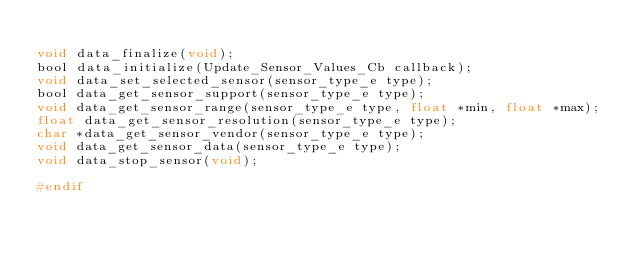Convert code to text. <code><loc_0><loc_0><loc_500><loc_500><_C_>
void data_finalize(void);
bool data_initialize(Update_Sensor_Values_Cb callback);
void data_set_selected_sensor(sensor_type_e type);
bool data_get_sensor_support(sensor_type_e type);
void data_get_sensor_range(sensor_type_e type, float *min, float *max);
float data_get_sensor_resolution(sensor_type_e type);
char *data_get_sensor_vendor(sensor_type_e type);
void data_get_sensor_data(sensor_type_e type);
void data_stop_sensor(void);

#endif
</code> 